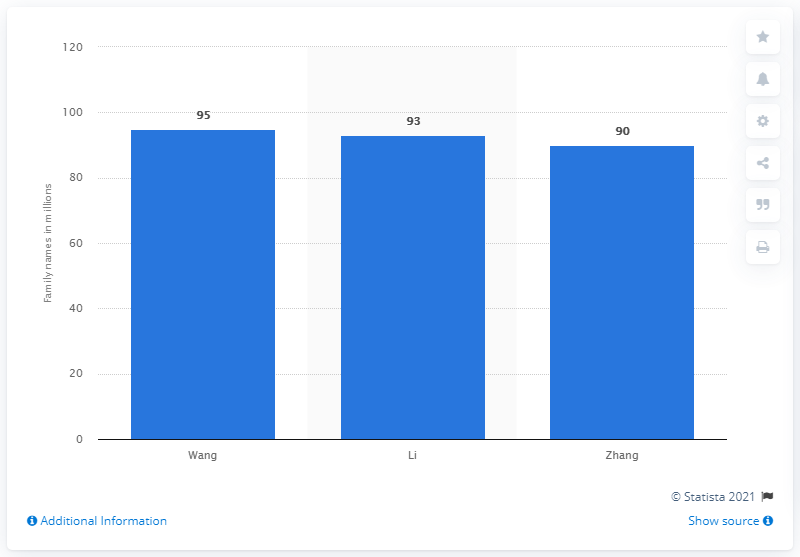Mention a couple of crucial points in this snapshot. The most common last name in China in 2013 was Wang. According to a recent survey, it is estimated that approximately 95% of the population in China has the last name Wang. 